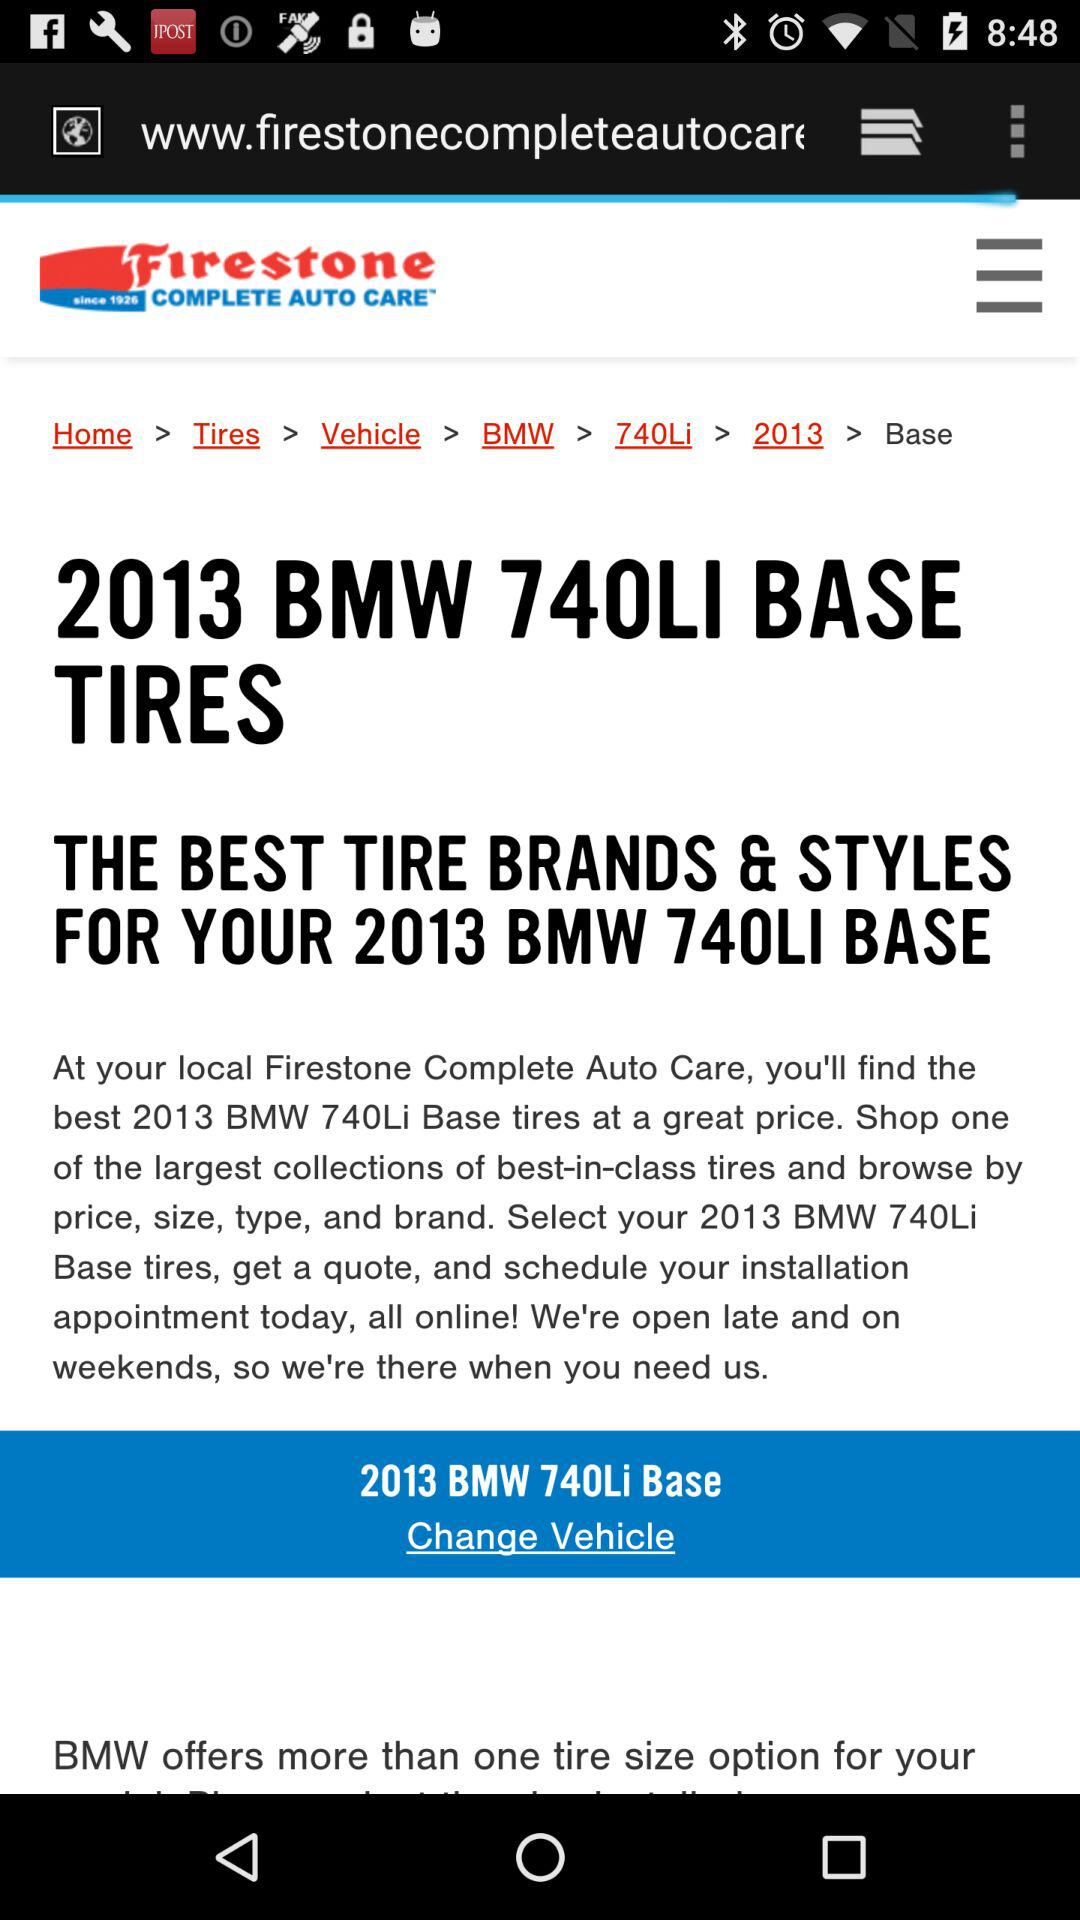What is the application name?
When the provided information is insufficient, respond with <no answer>. <no answer> 